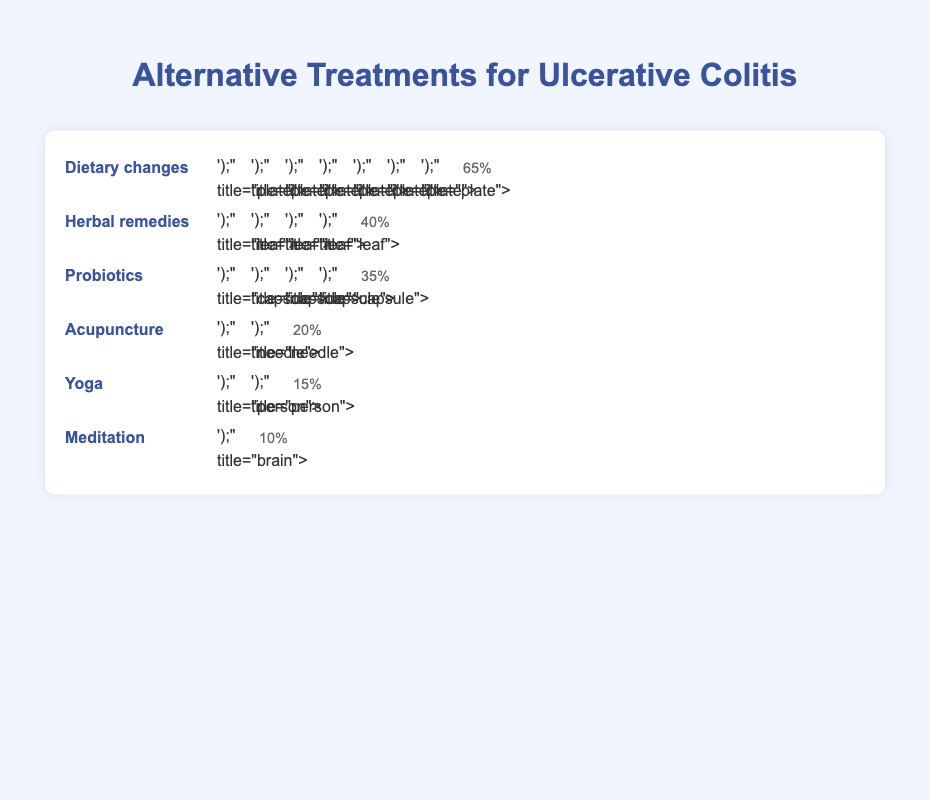What is the prevalence of dietary changes as an alternative treatment method for ulcerative colitis? The isotype plot shows multiple icons representing different treatment methods. To find the prevalence of dietary changes, look at the row labeled "Dietary changes" and note the percentage labeled next to it.
Answer: 65% How many treatment methods have a prevalence of 20% or higher? Identify and count treatments with prevalence percentages that are 20% or above. The treatments meeting this criterion are Dietary changes (65%), Herbal remedies (40%), and Probiotics (35%), and Acupuncture (20%).
Answer: 4 Which alternative treatment method is least prevalent according to the plot? Locate the treatment method with the smallest percentage value labeled next to its icons. The lowest prevalence is Meditation with 10%.
Answer: Meditation What is the combined prevalence of yoga and probiotics? Sum the prevalence percentages of Yoga (15%) and Probiotics (35%). Therefore, 15% + 35% equals 50%.
Answer: 50% Between probiotics and acupuncture, which has a higher prevalence and by how much? Compare the prevalence percentages of Probiotics (35%) and Acupuncture (20%). Subtract the lower percentage from the higher one: 35% - 20% = 15%.
Answer: Probiotics by 15% Which type of alternative treatment has more prevalence, herbal remedies or yoga? Compare the prevalence percentages of Herbal remedies (40%) and Yoga (15%). Herbal remedies have a higher prevalence.
Answer: Herbal remedies What is the average prevalence of all the listed alternative treatments? First, sum the prevalence percentages of all treatments: Dietary changes (65%) + Herbal remedies (40%) + Probiotics (35%) + Acupuncture (20%) + Yoga (15%) + Meditation (10%). Total is 185%. Then, divide by the number of treatments (6): 185% / 6 = 30.83%.
Answer: 30.83% Which treatment methods use the least common icon type, and what is the icon? Identify the various icon types and their occurrences. The least common icon is the "brain" used for Meditation, representing only 10%.
Answer: Meditation, brain 